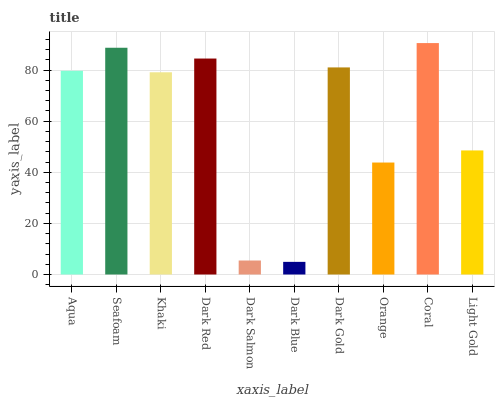Is Dark Blue the minimum?
Answer yes or no. Yes. Is Coral the maximum?
Answer yes or no. Yes. Is Seafoam the minimum?
Answer yes or no. No. Is Seafoam the maximum?
Answer yes or no. No. Is Seafoam greater than Aqua?
Answer yes or no. Yes. Is Aqua less than Seafoam?
Answer yes or no. Yes. Is Aqua greater than Seafoam?
Answer yes or no. No. Is Seafoam less than Aqua?
Answer yes or no. No. Is Aqua the high median?
Answer yes or no. Yes. Is Khaki the low median?
Answer yes or no. Yes. Is Orange the high median?
Answer yes or no. No. Is Coral the low median?
Answer yes or no. No. 